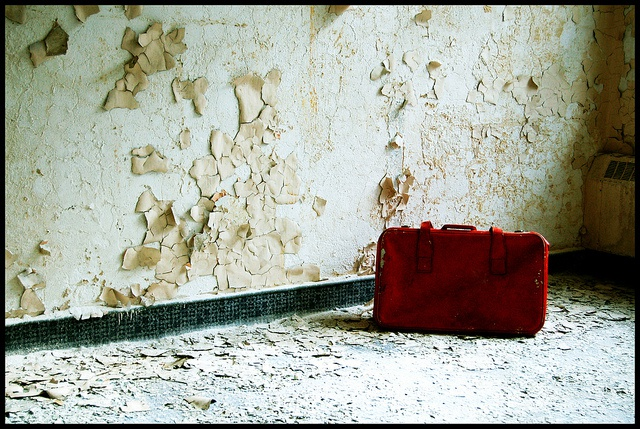Describe the objects in this image and their specific colors. I can see a suitcase in black, maroon, and red tones in this image. 